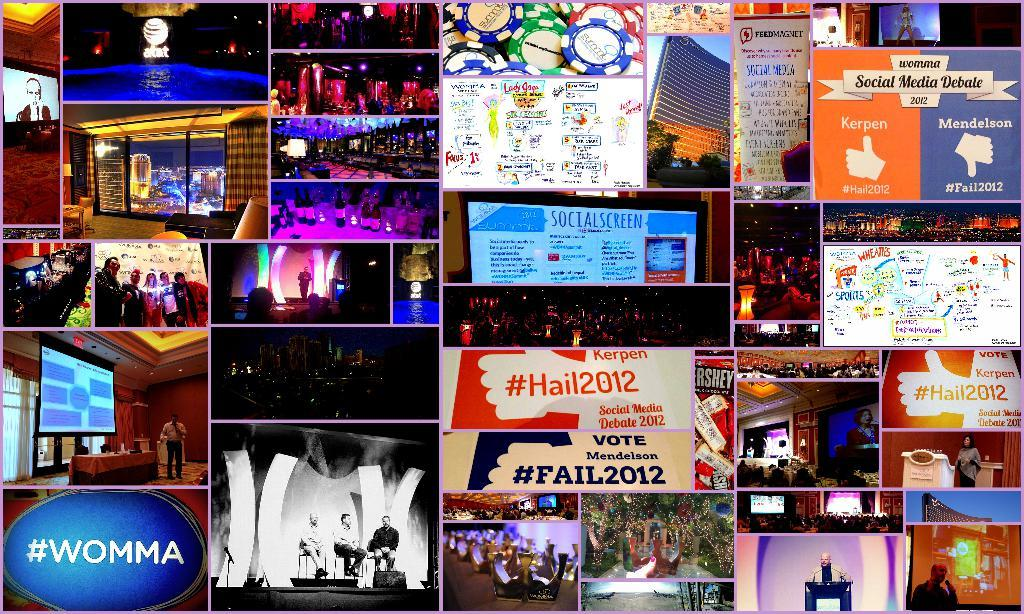<image>
Present a compact description of the photo's key features. the word womma is on the screen next to other items 